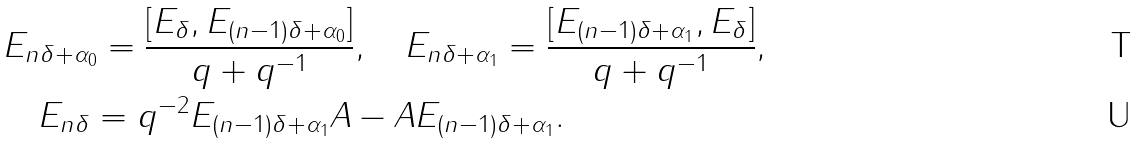<formula> <loc_0><loc_0><loc_500><loc_500>& E _ { n \delta + \alpha _ { 0 } } = \frac { [ E _ { \delta } , E _ { ( n - 1 ) \delta + \alpha _ { 0 } } ] } { q + q ^ { - 1 } } , \quad E _ { n \delta + \alpha _ { 1 } } = \frac { [ E _ { ( n - 1 ) \delta + \alpha _ { 1 } } , E _ { \delta } ] } { q + q ^ { - 1 } } , \\ & \quad E _ { n \delta } = q ^ { - 2 } E _ { ( n - 1 ) \delta + \alpha _ { 1 } } A - A E _ { ( n - 1 ) \delta + \alpha _ { 1 } } .</formula> 